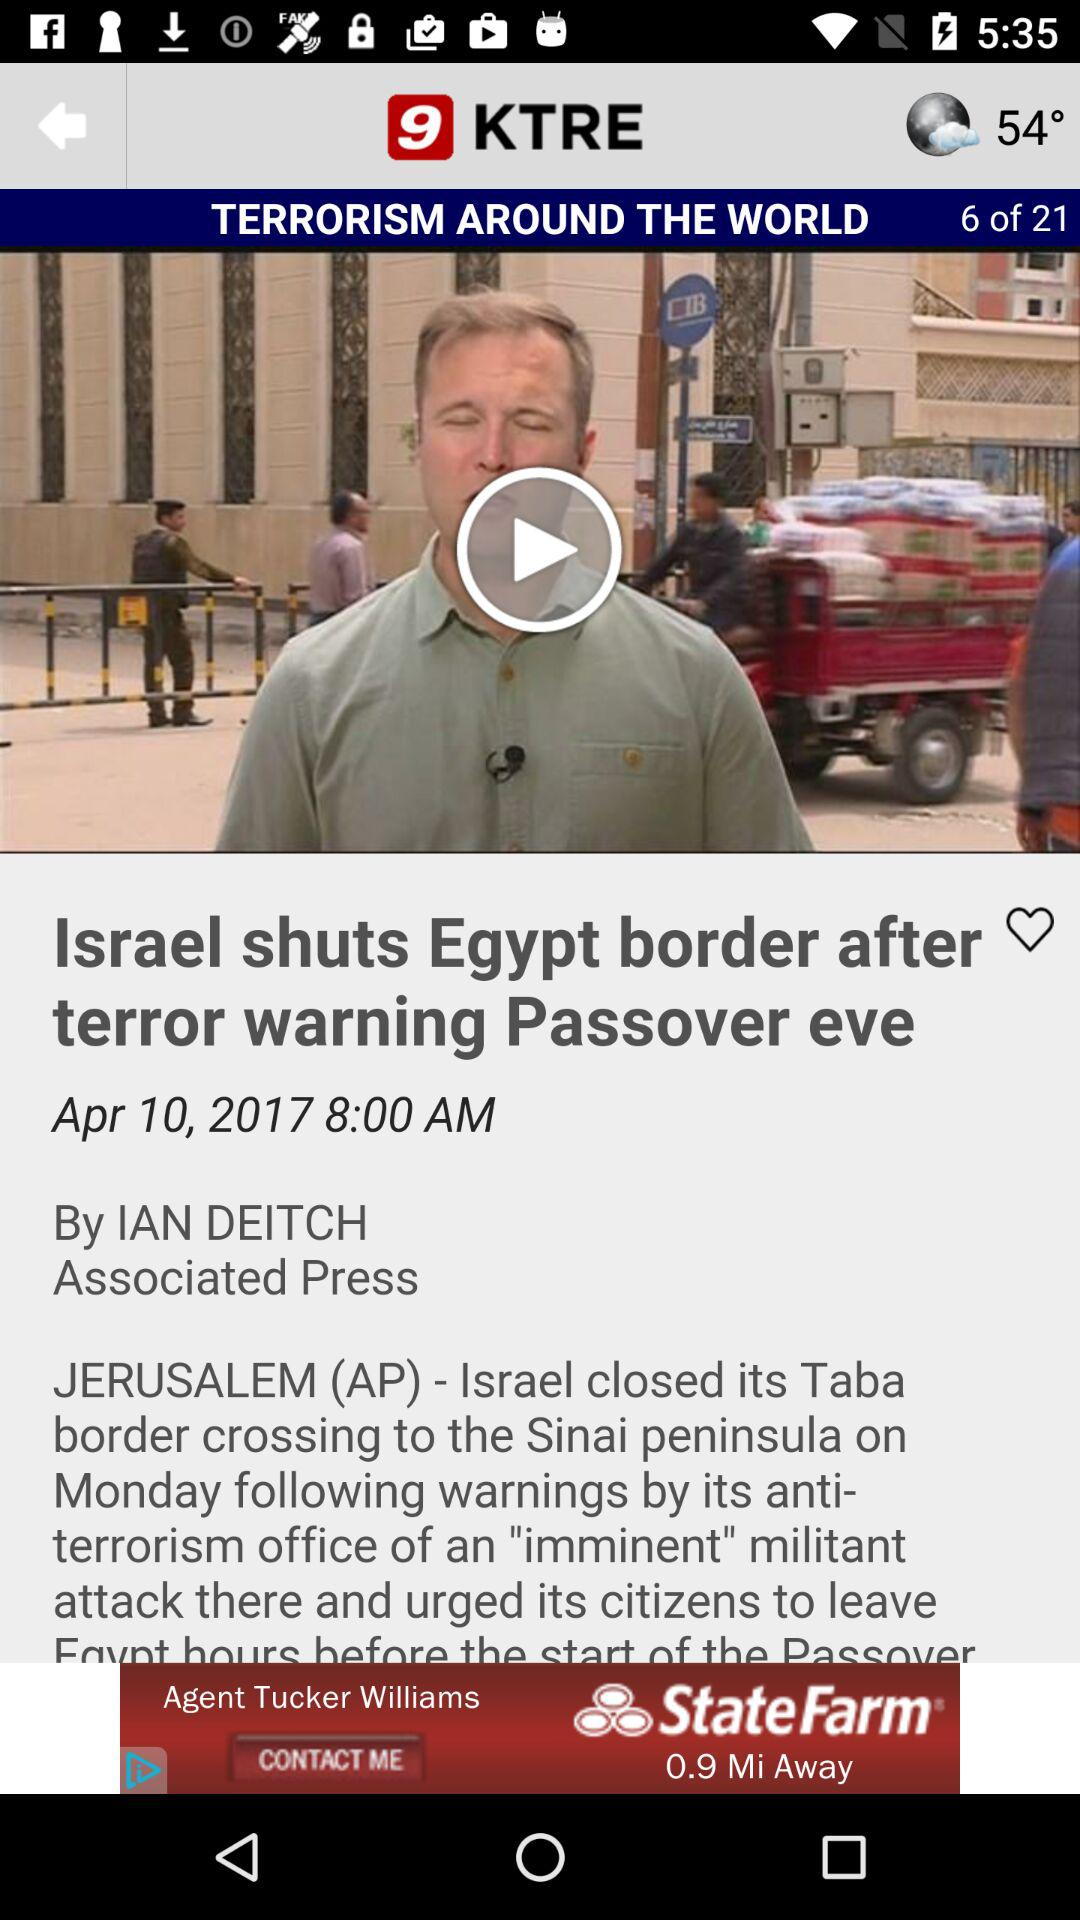What is the name of the application? The application name is "9 KTRE". 